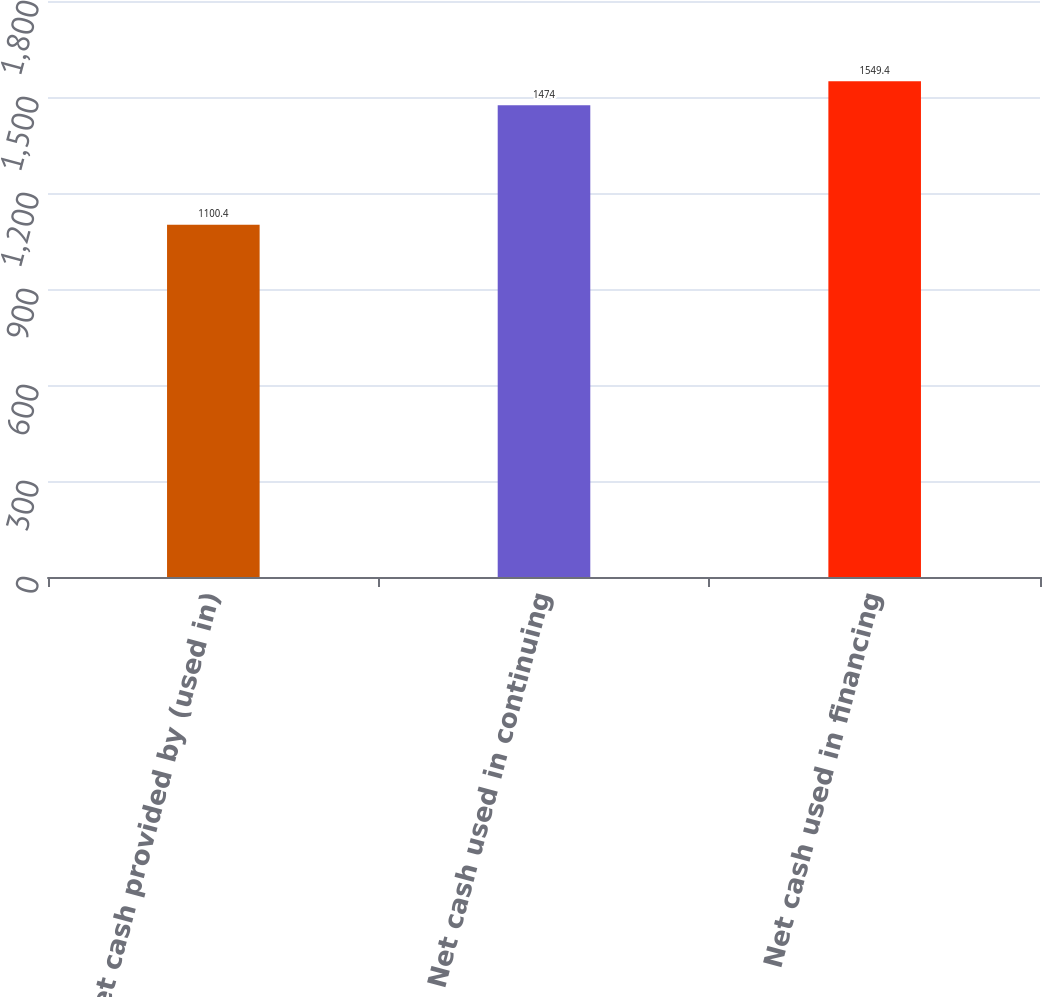<chart> <loc_0><loc_0><loc_500><loc_500><bar_chart><fcel>Net cash provided by (used in)<fcel>Net cash used in continuing<fcel>Net cash used in financing<nl><fcel>1100.4<fcel>1474<fcel>1549.4<nl></chart> 